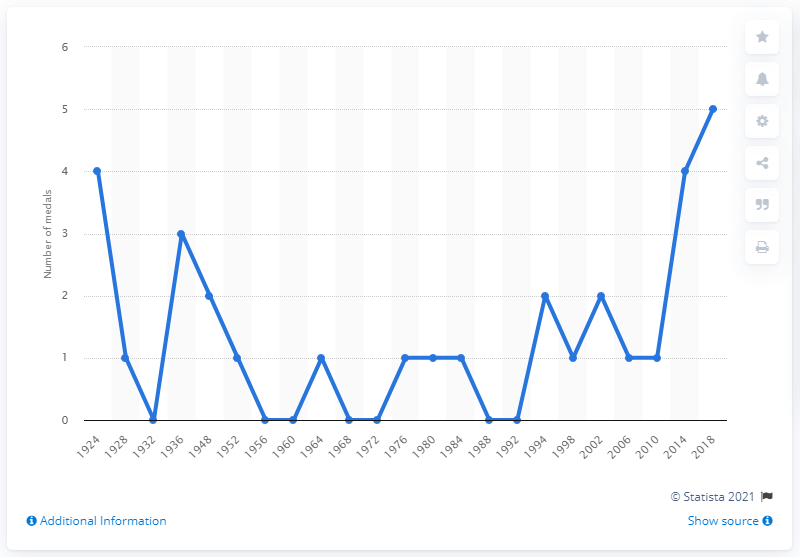Mention a couple of crucial points in this snapshot. In 1924, Great Britain athletes won the most medals at the Winter Olympics. 